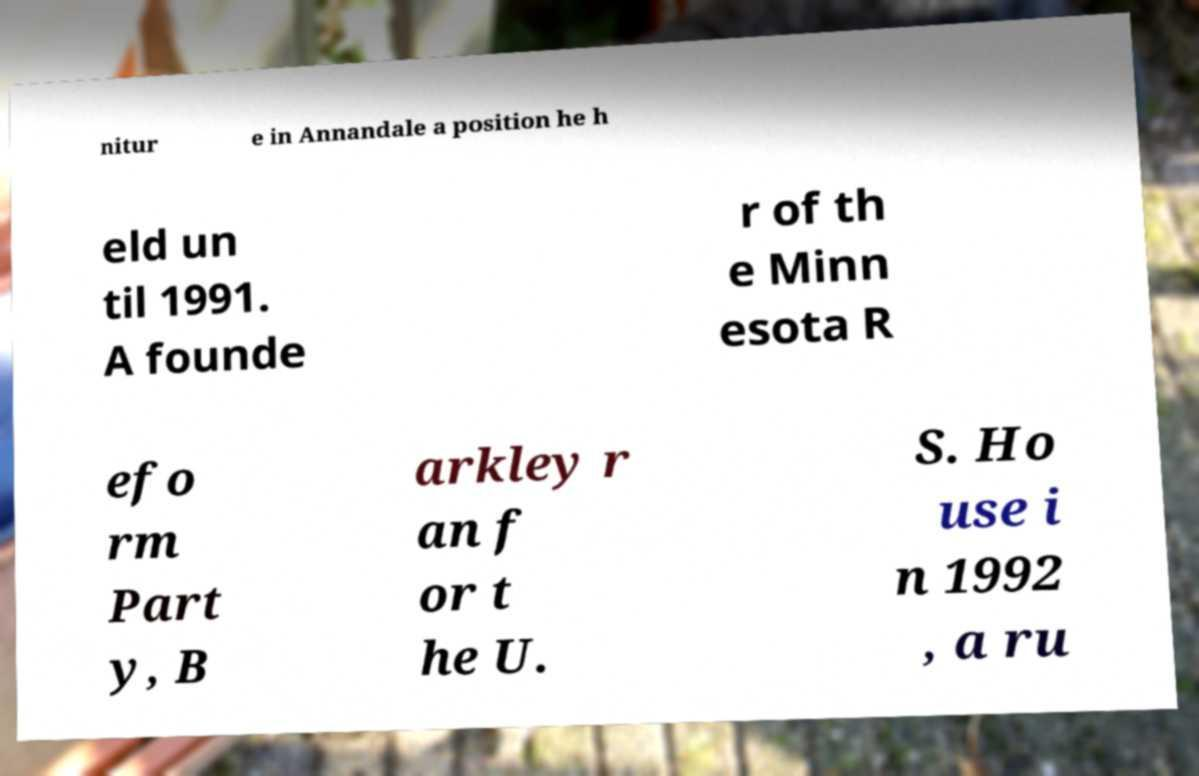Could you assist in decoding the text presented in this image and type it out clearly? nitur e in Annandale a position he h eld un til 1991. A founde r of th e Minn esota R efo rm Part y, B arkley r an f or t he U. S. Ho use i n 1992 , a ru 